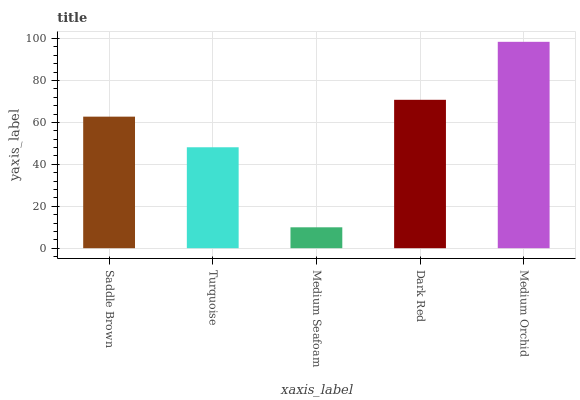Is Medium Seafoam the minimum?
Answer yes or no. Yes. Is Medium Orchid the maximum?
Answer yes or no. Yes. Is Turquoise the minimum?
Answer yes or no. No. Is Turquoise the maximum?
Answer yes or no. No. Is Saddle Brown greater than Turquoise?
Answer yes or no. Yes. Is Turquoise less than Saddle Brown?
Answer yes or no. Yes. Is Turquoise greater than Saddle Brown?
Answer yes or no. No. Is Saddle Brown less than Turquoise?
Answer yes or no. No. Is Saddle Brown the high median?
Answer yes or no. Yes. Is Saddle Brown the low median?
Answer yes or no. Yes. Is Medium Orchid the high median?
Answer yes or no. No. Is Medium Seafoam the low median?
Answer yes or no. No. 